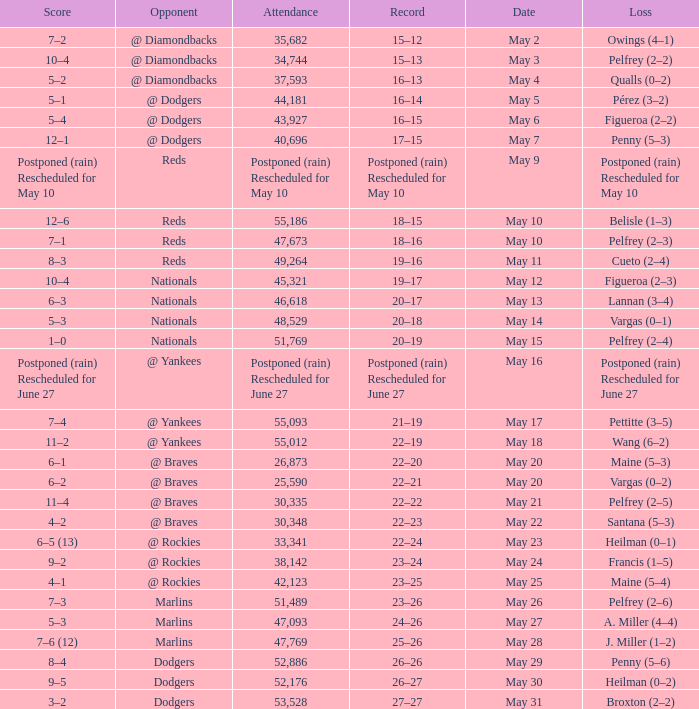Help me parse the entirety of this table. {'header': ['Score', 'Opponent', 'Attendance', 'Record', 'Date', 'Loss'], 'rows': [['7–2', '@ Diamondbacks', '35,682', '15–12', 'May 2', 'Owings (4–1)'], ['10–4', '@ Diamondbacks', '34,744', '15–13', 'May 3', 'Pelfrey (2–2)'], ['5–2', '@ Diamondbacks', '37,593', '16–13', 'May 4', 'Qualls (0–2)'], ['5–1', '@ Dodgers', '44,181', '16–14', 'May 5', 'Pérez (3–2)'], ['5–4', '@ Dodgers', '43,927', '16–15', 'May 6', 'Figueroa (2–2)'], ['12–1', '@ Dodgers', '40,696', '17–15', 'May 7', 'Penny (5–3)'], ['Postponed (rain) Rescheduled for May 10', 'Reds', 'Postponed (rain) Rescheduled for May 10', 'Postponed (rain) Rescheduled for May 10', 'May 9', 'Postponed (rain) Rescheduled for May 10'], ['12–6', 'Reds', '55,186', '18–15', 'May 10', 'Belisle (1–3)'], ['7–1', 'Reds', '47,673', '18–16', 'May 10', 'Pelfrey (2–3)'], ['8–3', 'Reds', '49,264', '19–16', 'May 11', 'Cueto (2–4)'], ['10–4', 'Nationals', '45,321', '19–17', 'May 12', 'Figueroa (2–3)'], ['6–3', 'Nationals', '46,618', '20–17', 'May 13', 'Lannan (3–4)'], ['5–3', 'Nationals', '48,529', '20–18', 'May 14', 'Vargas (0–1)'], ['1–0', 'Nationals', '51,769', '20–19', 'May 15', 'Pelfrey (2–4)'], ['Postponed (rain) Rescheduled for June 27', '@ Yankees', 'Postponed (rain) Rescheduled for June 27', 'Postponed (rain) Rescheduled for June 27', 'May 16', 'Postponed (rain) Rescheduled for June 27'], ['7–4', '@ Yankees', '55,093', '21–19', 'May 17', 'Pettitte (3–5)'], ['11–2', '@ Yankees', '55,012', '22–19', 'May 18', 'Wang (6–2)'], ['6–1', '@ Braves', '26,873', '22–20', 'May 20', 'Maine (5–3)'], ['6–2', '@ Braves', '25,590', '22–21', 'May 20', 'Vargas (0–2)'], ['11–4', '@ Braves', '30,335', '22–22', 'May 21', 'Pelfrey (2–5)'], ['4–2', '@ Braves', '30,348', '22–23', 'May 22', 'Santana (5–3)'], ['6–5 (13)', '@ Rockies', '33,341', '22–24', 'May 23', 'Heilman (0–1)'], ['9–2', '@ Rockies', '38,142', '23–24', 'May 24', 'Francis (1–5)'], ['4–1', '@ Rockies', '42,123', '23–25', 'May 25', 'Maine (5–4)'], ['7–3', 'Marlins', '51,489', '23–26', 'May 26', 'Pelfrey (2–6)'], ['5–3', 'Marlins', '47,093', '24–26', 'May 27', 'A. Miller (4–4)'], ['7–6 (12)', 'Marlins', '47,769', '25–26', 'May 28', 'J. Miller (1–2)'], ['8–4', 'Dodgers', '52,886', '26–26', 'May 29', 'Penny (5–6)'], ['9–5', 'Dodgers', '52,176', '26–27', 'May 30', 'Heilman (0–2)'], ['3–2', 'Dodgers', '53,528', '27–27', 'May 31', 'Broxton (2–2)']]} Score of postponed (rain) rescheduled for June 27 had what loss? Postponed (rain) Rescheduled for June 27. 